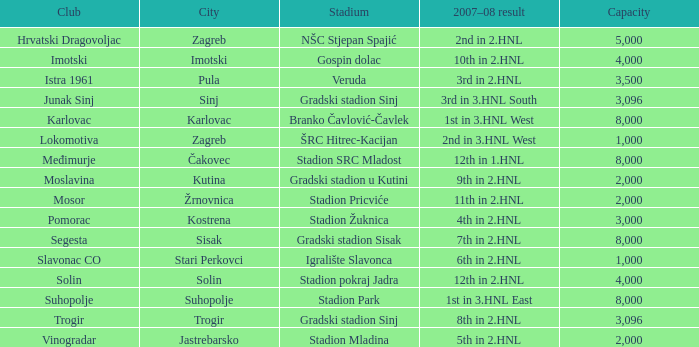Would you be able to parse every entry in this table? {'header': ['Club', 'City', 'Stadium', '2007–08 result', 'Capacity'], 'rows': [['Hrvatski Dragovoljac', 'Zagreb', 'NŠC Stjepan Spajić', '2nd in 2.HNL', '5,000'], ['Imotski', 'Imotski', 'Gospin dolac', '10th in 2.HNL', '4,000'], ['Istra 1961', 'Pula', 'Veruda', '3rd in 2.HNL', '3,500'], ['Junak Sinj', 'Sinj', 'Gradski stadion Sinj', '3rd in 3.HNL South', '3,096'], ['Karlovac', 'Karlovac', 'Branko Čavlović-Čavlek', '1st in 3.HNL West', '8,000'], ['Lokomotiva', 'Zagreb', 'ŠRC Hitrec-Kacijan', '2nd in 3.HNL West', '1,000'], ['Međimurje', 'Čakovec', 'Stadion SRC Mladost', '12th in 1.HNL', '8,000'], ['Moslavina', 'Kutina', 'Gradski stadion u Kutini', '9th in 2.HNL', '2,000'], ['Mosor', 'Žrnovnica', 'Stadion Pricviće', '11th in 2.HNL', '2,000'], ['Pomorac', 'Kostrena', 'Stadion Žuknica', '4th in 2.HNL', '3,000'], ['Segesta', 'Sisak', 'Gradski stadion Sisak', '7th in 2.HNL', '8,000'], ['Slavonac CO', 'Stari Perkovci', 'Igralište Slavonca', '6th in 2.HNL', '1,000'], ['Solin', 'Solin', 'Stadion pokraj Jadra', '12th in 2.HNL', '4,000'], ['Suhopolje', 'Suhopolje', 'Stadion Park', '1st in 3.HNL East', '8,000'], ['Trogir', 'Trogir', 'Gradski stadion Sinj', '8th in 2.HNL', '3,096'], ['Vinogradar', 'Jastrebarsko', 'Stadion Mladina', '5th in 2.HNL', '2,000']]} What stadium has kutina as the city? Gradski stadion u Kutini. 